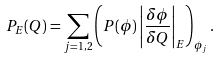Convert formula to latex. <formula><loc_0><loc_0><loc_500><loc_500>P _ { E } ( Q ) = \sum _ { j = 1 , 2 } \left ( P ( \phi ) \left | \frac { \delta \phi } { \delta Q } \right | _ { E } \right ) _ { \phi _ { j } } .</formula> 